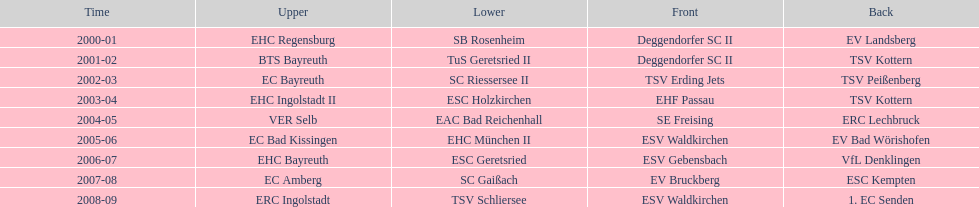Who won the south after esc geretsried did during the 2006-07 season? SC Gaißach. 